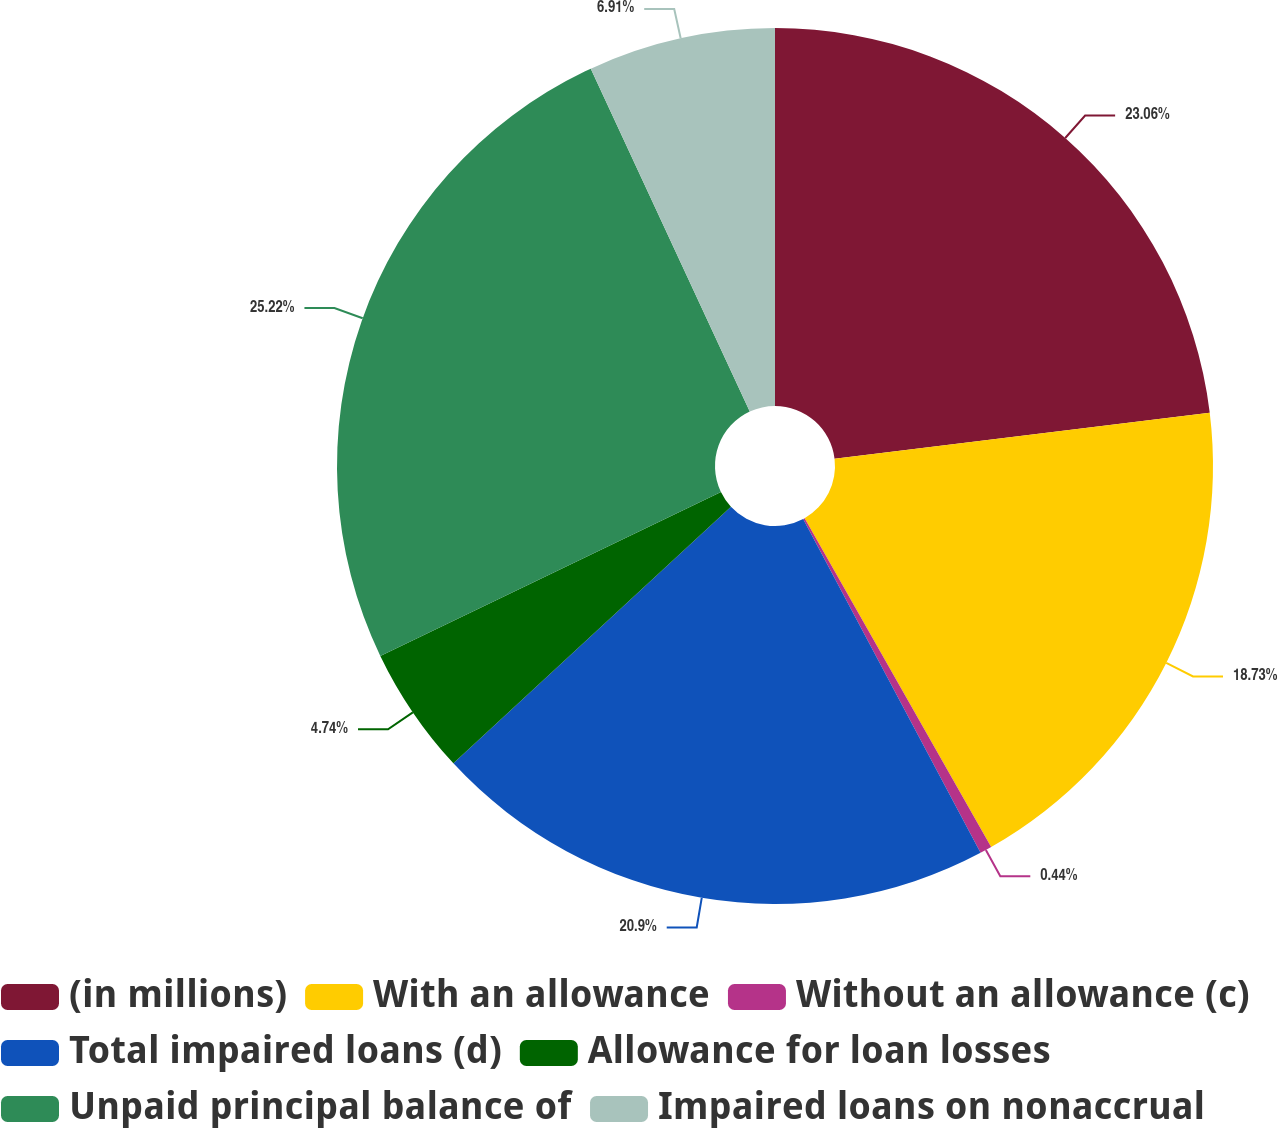Convert chart to OTSL. <chart><loc_0><loc_0><loc_500><loc_500><pie_chart><fcel>(in millions)<fcel>With an allowance<fcel>Without an allowance (c)<fcel>Total impaired loans (d)<fcel>Allowance for loan losses<fcel>Unpaid principal balance of<fcel>Impaired loans on nonaccrual<nl><fcel>23.06%<fcel>18.73%<fcel>0.44%<fcel>20.9%<fcel>4.74%<fcel>25.23%<fcel>6.91%<nl></chart> 